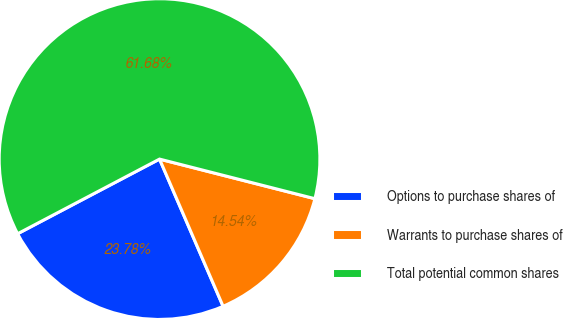Convert chart to OTSL. <chart><loc_0><loc_0><loc_500><loc_500><pie_chart><fcel>Options to purchase shares of<fcel>Warrants to purchase shares of<fcel>Total potential common shares<nl><fcel>23.78%<fcel>14.54%<fcel>61.68%<nl></chart> 